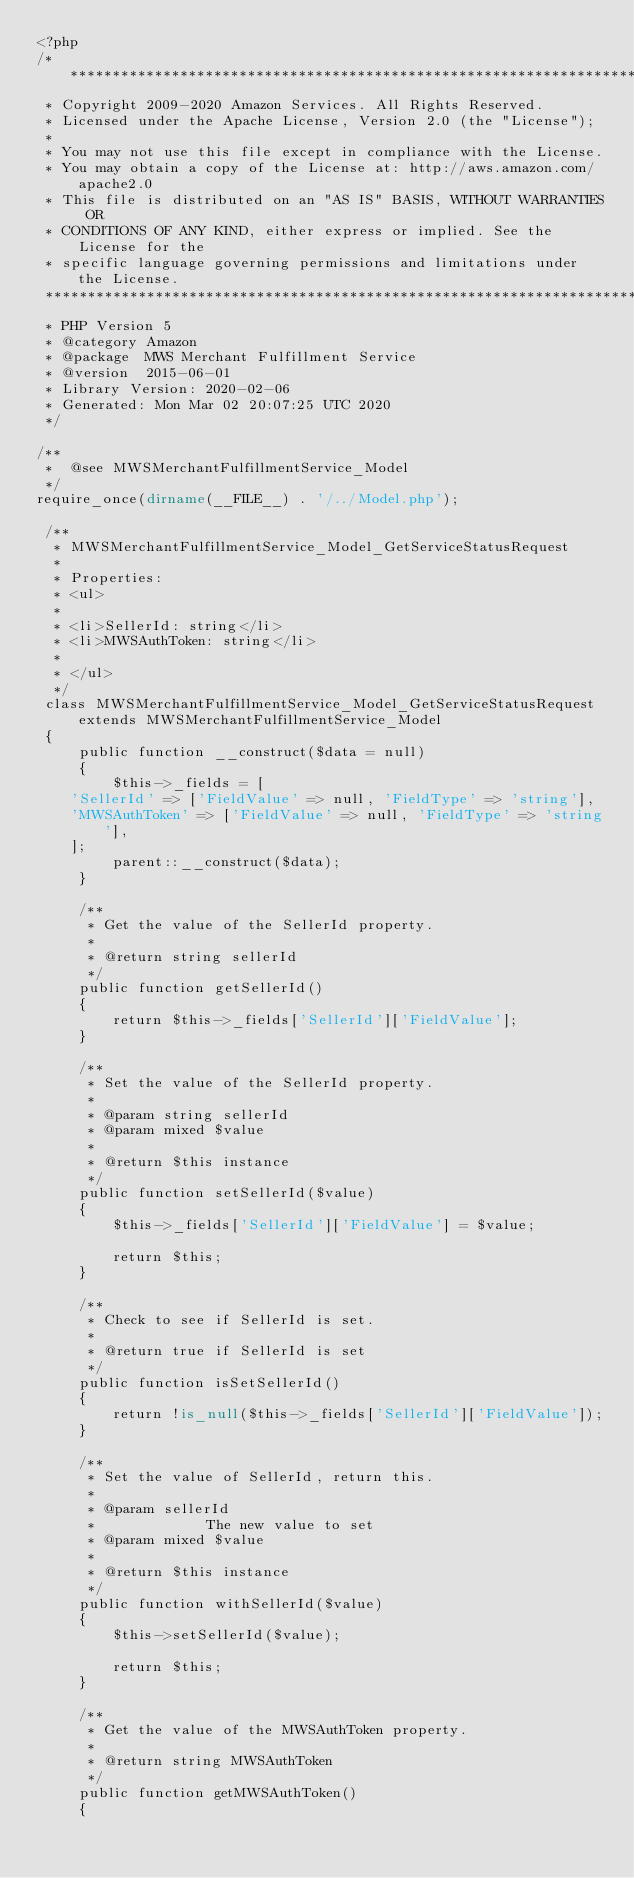<code> <loc_0><loc_0><loc_500><loc_500><_PHP_><?php
/*******************************************************************************
 * Copyright 2009-2020 Amazon Services. All Rights Reserved.
 * Licensed under the Apache License, Version 2.0 (the "License");
 *
 * You may not use this file except in compliance with the License.
 * You may obtain a copy of the License at: http://aws.amazon.com/apache2.0
 * This file is distributed on an "AS IS" BASIS, WITHOUT WARRANTIES OR
 * CONDITIONS OF ANY KIND, either express or implied. See the License for the
 * specific language governing permissions and limitations under the License.
 *******************************************************************************
 * PHP Version 5
 * @category Amazon
 * @package  MWS Merchant Fulfillment Service
 * @version  2015-06-01
 * Library Version: 2020-02-06
 * Generated: Mon Mar 02 20:07:25 UTC 2020
 */

/**
 *  @see MWSMerchantFulfillmentService_Model
 */
require_once(dirname(__FILE__) . '/../Model.php');

 /**
  * MWSMerchantFulfillmentService_Model_GetServiceStatusRequest
  *
  * Properties:
  * <ul>
  *
  * <li>SellerId: string</li>
  * <li>MWSAuthToken: string</li>
  *
  * </ul>
  */
 class MWSMerchantFulfillmentService_Model_GetServiceStatusRequest extends MWSMerchantFulfillmentService_Model
 {
     public function __construct($data = null)
     {
         $this->_fields = [
    'SellerId' => ['FieldValue' => null, 'FieldType' => 'string'],
    'MWSAuthToken' => ['FieldValue' => null, 'FieldType' => 'string'],
    ];
         parent::__construct($data);
     }

     /**
      * Get the value of the SellerId property.
      *
      * @return string sellerId
      */
     public function getSellerId()
     {
         return $this->_fields['SellerId']['FieldValue'];
     }

     /**
      * Set the value of the SellerId property.
      *
      * @param string sellerId
      * @param mixed $value
      *
      * @return $this instance
      */
     public function setSellerId($value)
     {
         $this->_fields['SellerId']['FieldValue'] = $value;

         return $this;
     }

     /**
      * Check to see if SellerId is set.
      *
      * @return true if SellerId is set
      */
     public function isSetSellerId()
     {
         return !is_null($this->_fields['SellerId']['FieldValue']);
     }

     /**
      * Set the value of SellerId, return this.
      *
      * @param sellerId
      *             The new value to set
      * @param mixed $value
      *
      * @return $this instance
      */
     public function withSellerId($value)
     {
         $this->setSellerId($value);

         return $this;
     }

     /**
      * Get the value of the MWSAuthToken property.
      *
      * @return string MWSAuthToken
      */
     public function getMWSAuthToken()
     {</code> 